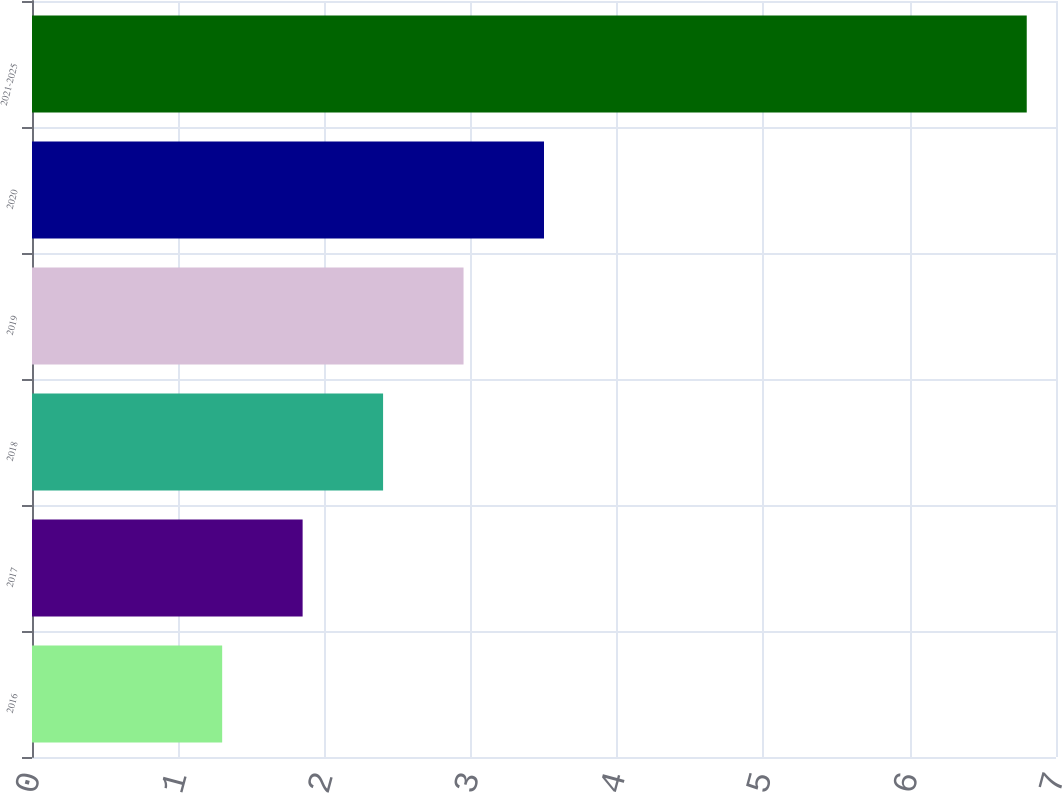Convert chart. <chart><loc_0><loc_0><loc_500><loc_500><bar_chart><fcel>2016<fcel>2017<fcel>2018<fcel>2019<fcel>2020<fcel>2021-2025<nl><fcel>1.3<fcel>1.85<fcel>2.4<fcel>2.95<fcel>3.5<fcel>6.8<nl></chart> 